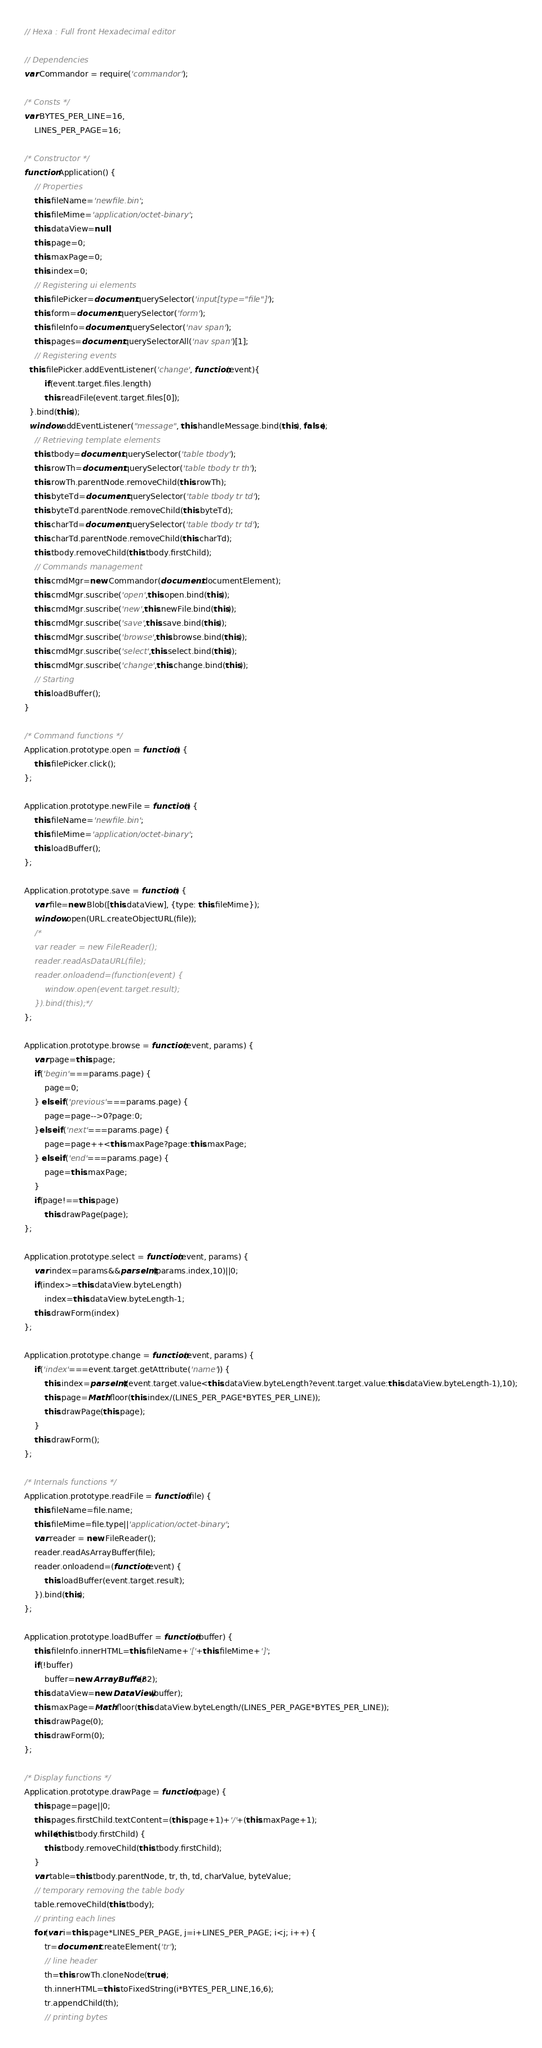Convert code to text. <code><loc_0><loc_0><loc_500><loc_500><_JavaScript_>// Hexa : Full front Hexadecimal editor

// Dependencies
var Commandor = require('commandor');

/* Consts */
var BYTES_PER_LINE=16,
	LINES_PER_PAGE=16;

/* Constructor */
function Application() {
	// Properties
	this.fileName='newfile.bin';
	this.fileMime='application/octet-binary';
	this.dataView=null;
	this.page=0;
	this.maxPage=0;
	this.index=0;
	// Registering ui elements
	this.filePicker=document.querySelector('input[type="file"]');
	this.form=document.querySelector('form');
	this.fileInfo=document.querySelector('nav span');
	this.pages=document.querySelectorAll('nav span')[1];
	// Registering events
  this.filePicker.addEventListener('change', function(event){
		if(event.target.files.length)
	  	this.readFile(event.target.files[0]);
  }.bind(this));
  window.addEventListener("message", this.handleMessage.bind(this), false);
	// Retrieving template elements
	this.tbody=document.querySelector('table tbody');
	this.rowTh=document.querySelector('table tbody tr th');
	this.rowTh.parentNode.removeChild(this.rowTh);
	this.byteTd=document.querySelector('table tbody tr td');
	this.byteTd.parentNode.removeChild(this.byteTd);
	this.charTd=document.querySelector('table tbody tr td');
	this.charTd.parentNode.removeChild(this.charTd);
	this.tbody.removeChild(this.tbody.firstChild);
	// Commands management
	this.cmdMgr=new Commandor(document.documentElement);
	this.cmdMgr.suscribe('open',this.open.bind(this));
	this.cmdMgr.suscribe('new',this.newFile.bind(this));
	this.cmdMgr.suscribe('save',this.save.bind(this));
	this.cmdMgr.suscribe('browse',this.browse.bind(this));
	this.cmdMgr.suscribe('select',this.select.bind(this));
	this.cmdMgr.suscribe('change',this.change.bind(this));
	// Starting
	this.loadBuffer();
}

/* Command functions */
Application.prototype.open = function() {
	this.filePicker.click();
};

Application.prototype.newFile = function() {
	this.fileName='newfile.bin';
	this.fileMime='application/octet-binary';
	this.loadBuffer();
};

Application.prototype.save = function() {
	var file=new Blob([this.dataView], {type: this.fileMime});
	window.open(URL.createObjectURL(file));
	/*
	var reader = new FileReader();
	reader.readAsDataURL(file);
	reader.onloadend=(function(event) {
		window.open(event.target.result);
	}).bind(this);*/
};

Application.prototype.browse = function(event, params) {
	var page=this.page;
	if('begin'===params.page) {
		page=0;
	} else if('previous'===params.page) {
		page=page-->0?page:0;
	}else if('next'===params.page) {
		page=page++<this.maxPage?page:this.maxPage;
	} else if('end'===params.page) {
		page=this.maxPage;
	}
	if(page!==this.page)
		this.drawPage(page);
};

Application.prototype.select = function(event, params) {
	var index=params&&parseInt(params.index,10)||0;
	if(index>=this.dataView.byteLength)
		index=this.dataView.byteLength-1;
	this.drawForm(index)
};

Application.prototype.change = function(event, params) {
	if('index'===event.target.getAttribute('name')) {
		this.index=parseInt((event.target.value<this.dataView.byteLength?event.target.value:this.dataView.byteLength-1),10);
		this.page=Math.floor(this.index/(LINES_PER_PAGE*BYTES_PER_LINE));
		this.drawPage(this.page);
	}
	this.drawForm();
};

/* Internals functions */
Application.prototype.readFile = function(file) {
	this.fileName=file.name;
	this.fileMime=file.type||'application/octet-binary';
	var reader = new FileReader();
	reader.readAsArrayBuffer(file);
	reader.onloadend=(function(event) {
		this.loadBuffer(event.target.result);
	}).bind(this);
};

Application.prototype.loadBuffer = function(buffer) {
	this.fileInfo.innerHTML=this.fileName+'['+this.fileMime+']';
	if(!buffer)
		buffer=new ArrayBuffer(32);
	this.dataView=new DataView(buffer);
	this.maxPage=Math.floor(this.dataView.byteLength/(LINES_PER_PAGE*BYTES_PER_LINE));
	this.drawPage(0);
	this.drawForm(0);
};

/* Display functions */
Application.prototype.drawPage = function(page) {
	this.page=page||0;
	this.pages.firstChild.textContent=(this.page+1)+'/'+(this.maxPage+1);
	while(this.tbody.firstChild) {
		this.tbody.removeChild(this.tbody.firstChild);
	}
	var table=this.tbody.parentNode, tr, th, td, charValue, byteValue;
	// temporary removing the table body
	table.removeChild(this.tbody);
	// printing each lines
	for(var i=this.page*LINES_PER_PAGE, j=i+LINES_PER_PAGE; i<j; i++) {
		tr=document.createElement('tr');
		// line header
		th=this.rowTh.cloneNode(true);
		th.innerHTML=this.toFixedString(i*BYTES_PER_LINE,16,6);
		tr.appendChild(th);
		// printing bytes</code> 